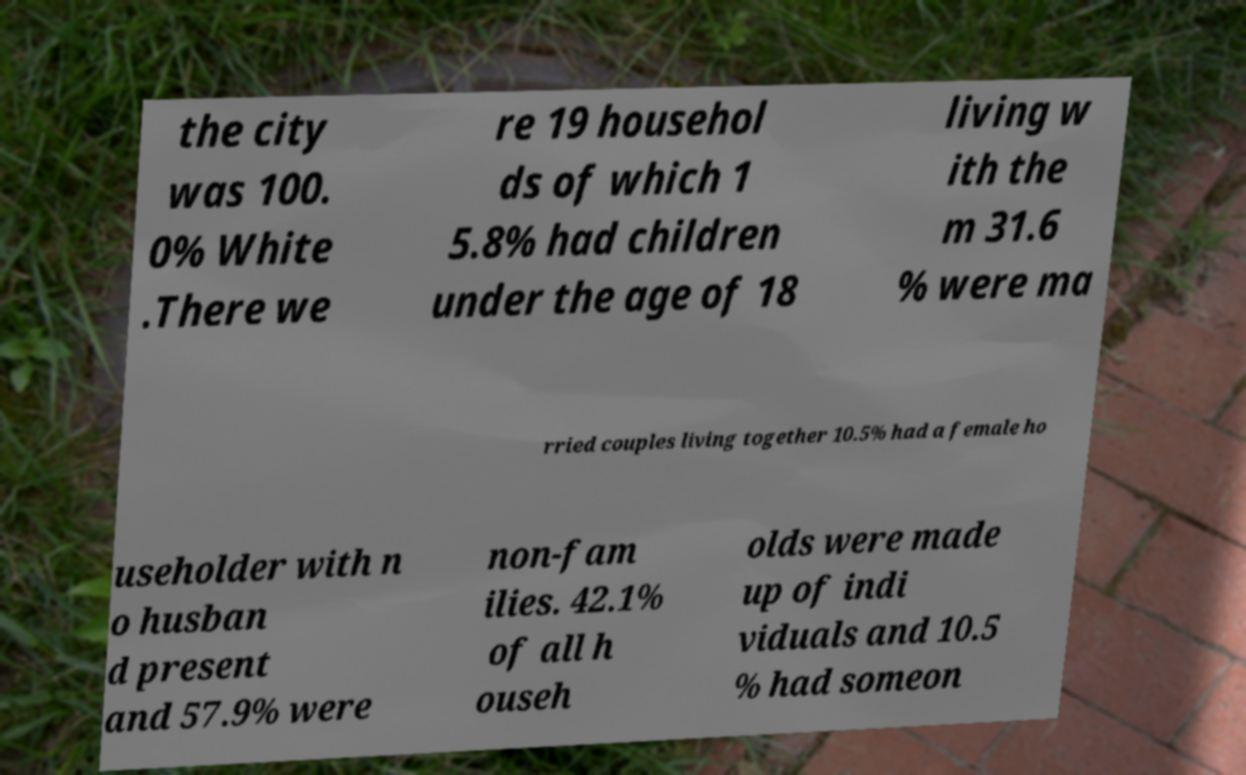Please read and relay the text visible in this image. What does it say? the city was 100. 0% White .There we re 19 househol ds of which 1 5.8% had children under the age of 18 living w ith the m 31.6 % were ma rried couples living together 10.5% had a female ho useholder with n o husban d present and 57.9% were non-fam ilies. 42.1% of all h ouseh olds were made up of indi viduals and 10.5 % had someon 